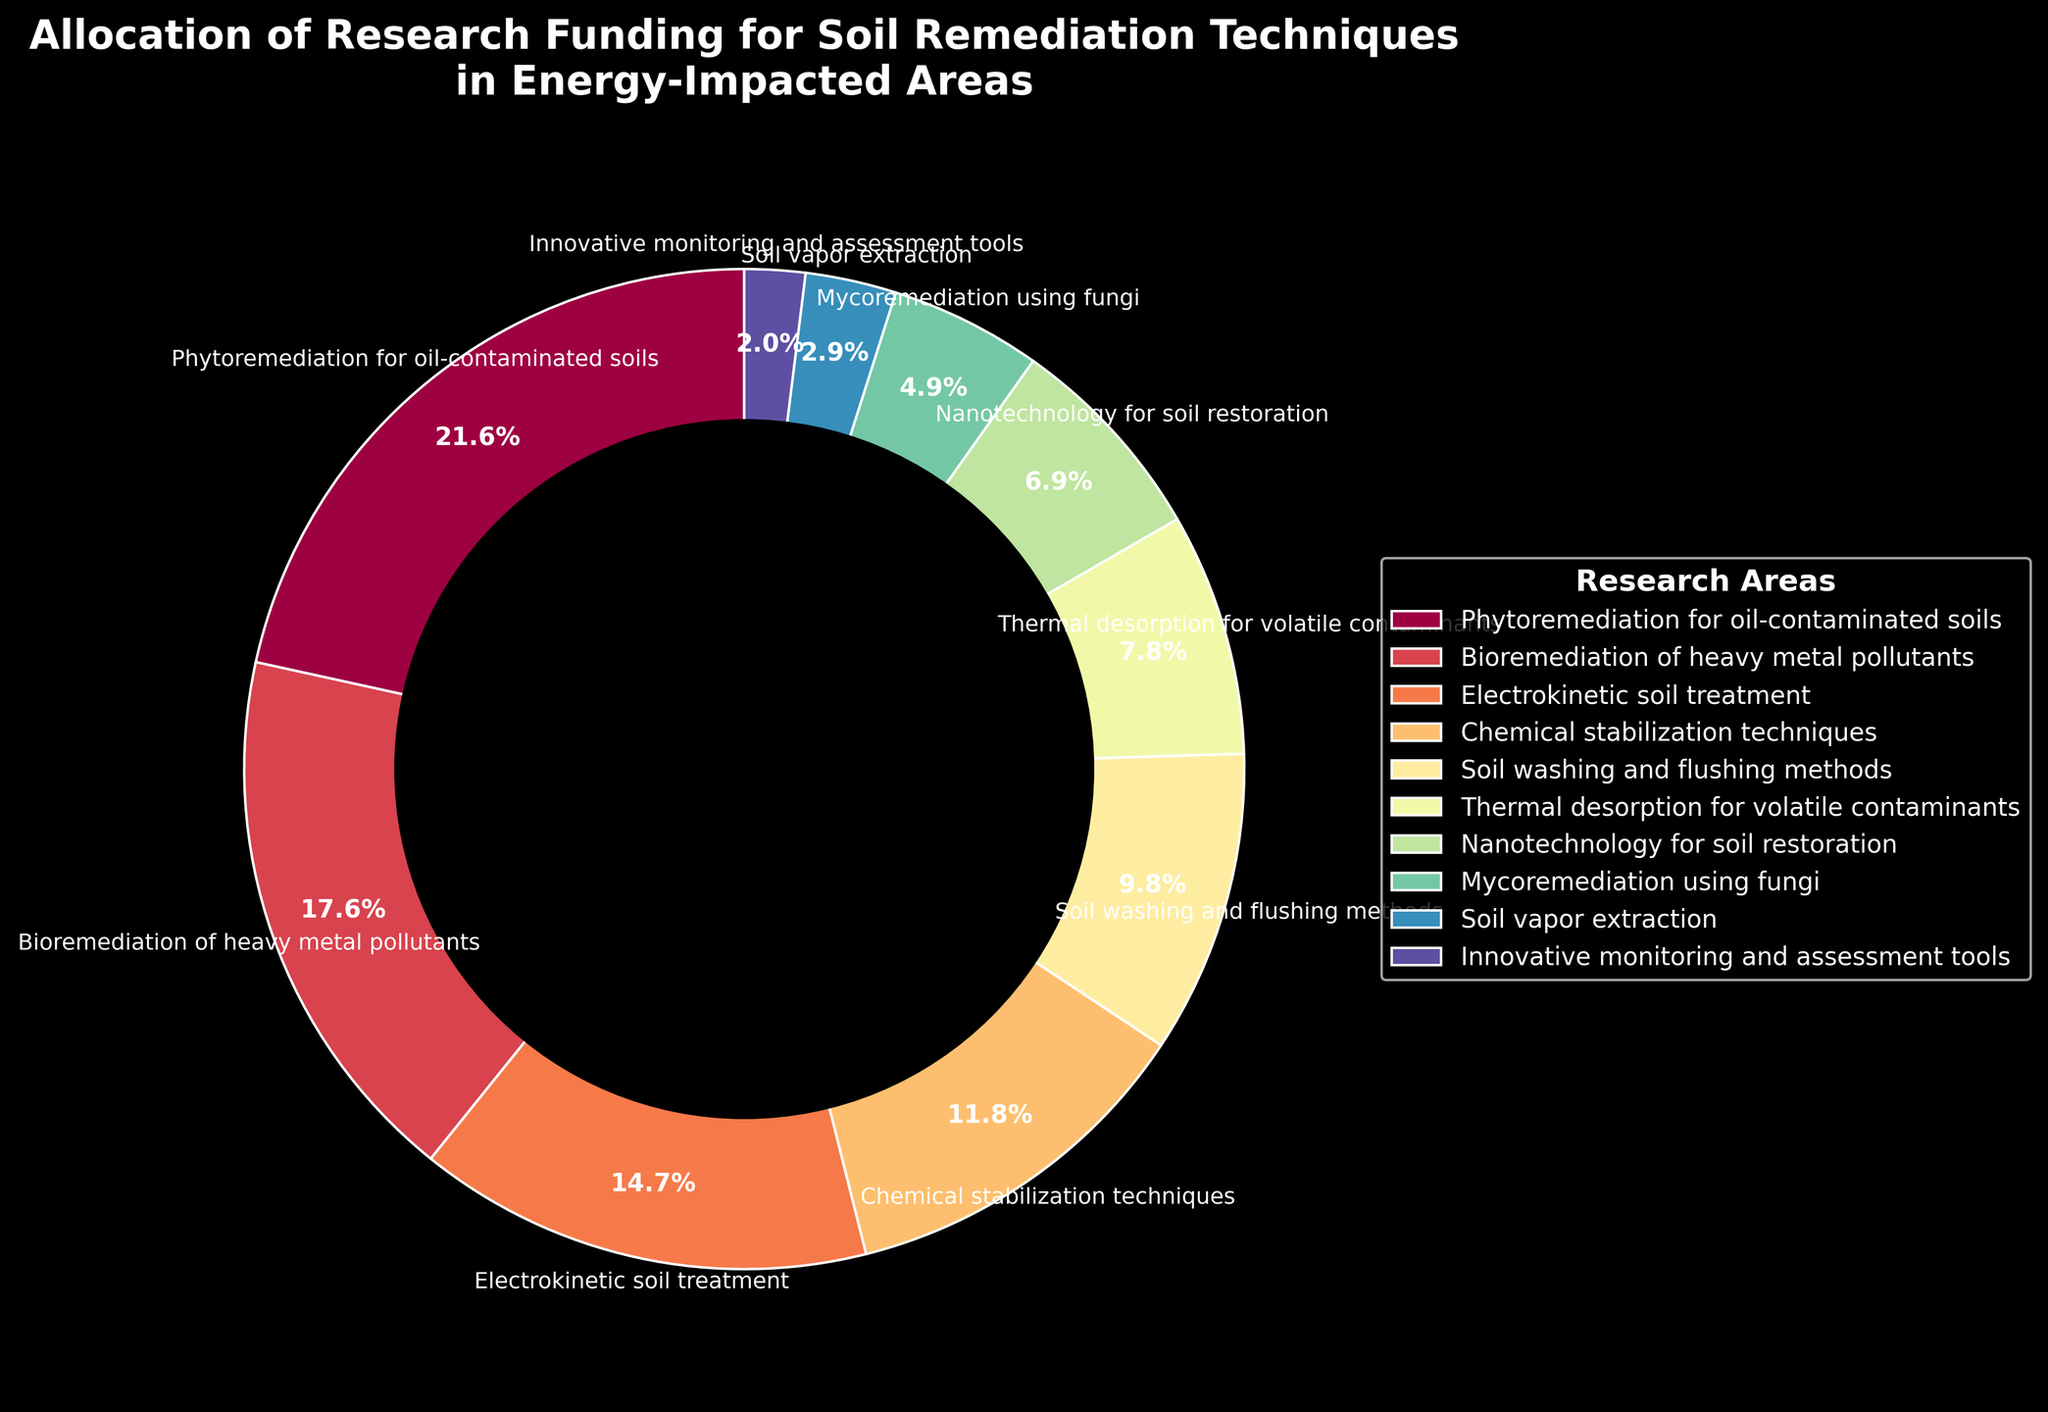What's the largest allocation of research funding? The largest segment in the pie chart indicates the highest funding. The segment labeled "Phytoremediation for oil-contaminated soils" occupies 22%.
Answer: Phytoremediation for oil-contaminated soils Which research area has the smallest percentage of funding? The smallest slice of the pie represents the least funding. "Innovative monitoring and assessment tools" has a small slice labeled with 2%.
Answer: Innovative monitoring and assessment tools What's the approximate total percentage of funding allocated to "Bioremediation of heavy metal pollutants" and "Thermal desorption for volatile contaminants"? Adding the percentages of "Bioremediation of heavy metal pollutants" (18%) and "Thermal desorption for volatile contaminants" (8%) gives 18 + 8 = 26.
Answer: 26% Which research area has a percentage closest to the average funding allocated across all areas? To find the average, sum all percentages (100%) and divide by the number of areas (10). The average is 100 / 10 = 10%. The area closest to 10% is "Soil washing and flushing methods" with 10%.
Answer: Soil washing and flushing methods How does the funding for "Electrokinetic soil treatment" compare to "Chemical stabilization techniques"? Comparing the two segments, "Electrokinetic soil treatment" has 15% while "Chemical stabilization techniques" has 12%. 15 is greater than 12.
Answer: Electrokinetic soil treatment What is the sum of the funding percentages for "Nanotechnology for soil restoration" and "Mycoremediation using fungi"? Adding the two percentages: "Nanotechnology for soil restoration" (7%) and "Mycoremediation using fungi" (5%) gives 7 + 5 = 12.
Answer: 12% Are there more research areas with funding greater than or equal to 10% or less than 10%? Count the areas: Greater than/equal to 10% (22%, 18%, 15%, 12%, 10%) = 5 areas. Less than 10% (8%, 7%, 5%, 3%, 2%) = 5 areas. Both counts are equal.
Answer: Equal Which slice has the second smallest allocation, and what visual characteristics confirm it? The second smallest slice represents "Soil vapor extraction" with 3%. The smallest slice "Innovative monitoring and assessment tools" is visually smallest, with "Soil vapor extraction" being the next smallest.
Answer: Soil vapor extraction What is the difference in funding percentages between "Phytoremediation for oil-contaminated soils" and "Chemical stabilization techniques"? Subtract "Chemical stabilization techniques" (12%) from "Phytoremediation for oil-contaminated soils" (22%) gives 22 - 12 = 10.
Answer: 10% What is the combined percentage of funding allocation for the three techniques with the highest funding? The three highest percentages are: "Phytoremediation for oil-contaminated soils" (22%), "Bioremediation of heavy metal pollutants" (18%), and "Electrokinetic soil treatment" (15%). Adding them gives 22 + 18 + 15 = 55.
Answer: 55% 